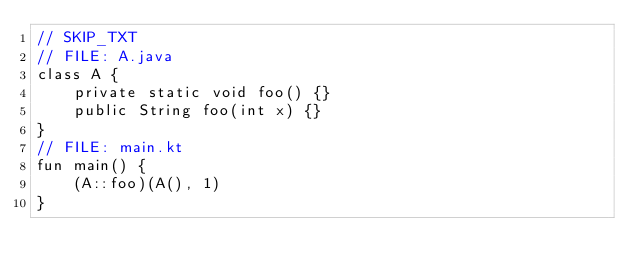<code> <loc_0><loc_0><loc_500><loc_500><_Kotlin_>// SKIP_TXT
// FILE: A.java
class A {
    private static void foo() {}
    public String foo(int x) {}
}
// FILE: main.kt
fun main() {
    (A::foo)(A(), 1)
}
</code> 